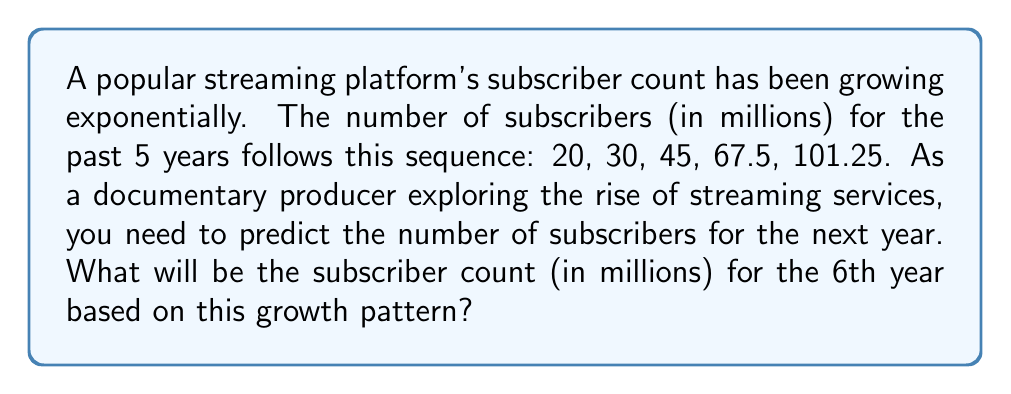Teach me how to tackle this problem. To solve this problem, we need to identify the growth factor between each year:

1) From year 1 to 2: $\frac{30}{20} = 1.5$
2) From year 2 to 3: $\frac{45}{30} = 1.5$
3) From year 3 to 4: $\frac{67.5}{45} = 1.5$
4) From year 4 to 5: $\frac{101.25}{67.5} = 1.5$

We can see that the growth factor is consistent at 1.5, or 50% increase each year.

To find the 6th year's subscriber count, we multiply the 5th year's count by 1.5:

$$ 101.25 \times 1.5 = 151.875 $$

Therefore, the predicted subscriber count for the 6th year is 151.875 million.
Answer: 151.875 million 